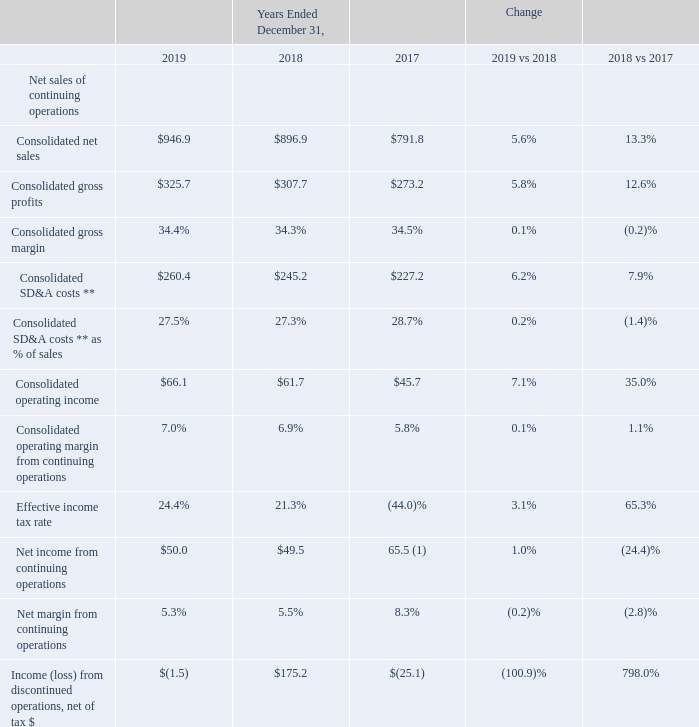GAAP Results of Operations
Key Performance Indicators* (in millions):
* excludes discontinued operations (See Note 5 of Notes to Consolidated Financial Statements).
** excludes special charges, net (See Note 5 of Notes to Consolidated Financial Statements).
1 Includes $20.0 million of income tax benefits primarily related to the reversal of valuation allowances against the Company's deferred tax assets and the
impacts of U.S. tax reform enacted in Q4 of 2017.
What is the change in consolidated net sales between 2019 vs 2018 and 2018 vs 2017 respectively? 5.6%, 13.3%. What is the change in consolidated gross profits between 2019 vs 2018 and 2018 vs 2017 respectively? 5.8%, 12.6%. What is the change in consolidated gross margins between 2019 vs 2018 and 2018 vs 2017 respectively? 0.1%, (0.2)%. What is the total consolidated net sales in 2019 and 2018?
Answer scale should be: million. 946.9 +896.9 
Answer: 1843.8. What is the total consolidated net sales in 2017 and 2018
Answer scale should be: million. 896.9 + 791.8 
Answer: 1688.7. What is the change in consolidated gross profit between 2017 and 2018?
Answer scale should be: million. 307.7 - 273.2 
Answer: 34.5. 